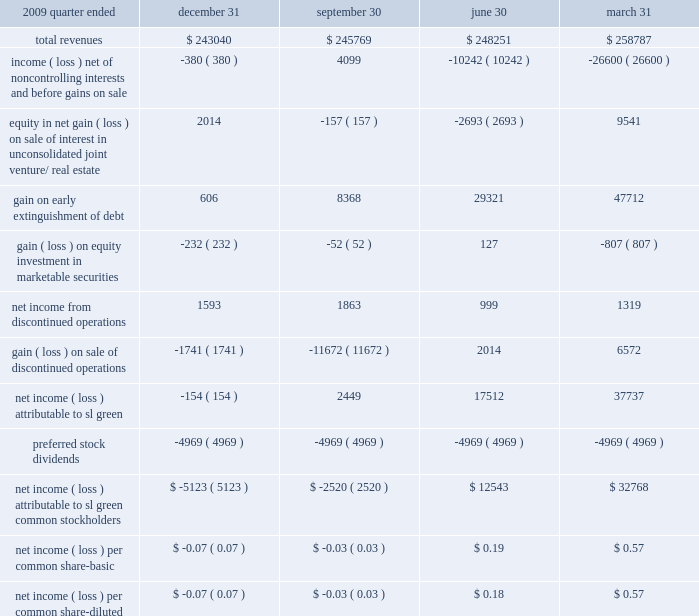22 2002subsequent events in january 2011 , we purchased cif 2019s 49.9% ( 49.9 % ) interest in 521 fifth avenue , thereby assuming full ownership of the building .
The transaction values the consolidated interest at approximately $ 245.7 a0million .
In january 2011 , we repaid our $ 84.8 a0million , 5.15% ( 5.15 % ) unsecured notes at par on their maturity date .
In january 2011 , we , along with the moinian group , completed the recapitalization of 3 columbus circle .
The recapitalization included a $ 138 a0million equity investment by sl a0green , a portion of which was in the form of sl a0green operating partnership units .
We believe the property is now fully capitalized for all costs necessary to complete the redevelop- ment and lease-up of the building .
The previously existing mortgage has been refinanced with a bridge loan provided by sl a0green and deutsche bank , which we intend to be further refinanced by third-party lenders at a later date .
On february a010 , 2011 , the company and the operating partnership entered into atm equity offering sales agreements with each of merrill lynch , pierce , fenner a0& smith incorporated and morgan stanley a0& a0co .
Incorporated , to sell shares of the company 2019s common stock , from time to time , through a $ 250.0 a0 million 201cat the market 201d equity offering program under which merrill lynch , pierce , fenner a0& smith incorporated and morgan stanley a0& a0co .
Incorporated are acting as sales agents .
As of february a022 , 2011 , we sold approximately 2.0 a0million shares our common stock through the program for aggregate proceeds of $ 144.1 a0million .
2009 quarter ended december a031 september a030 june a030 march a031 .
88 sl green realty corp .
2010 annual report notes to consolidated financial statements .
In 2009 what was the average revenues per quarter in millions? 
Computations: ((258787 + (248251 + (243040 + 245769))) / 4)
Answer: 248961.75. 